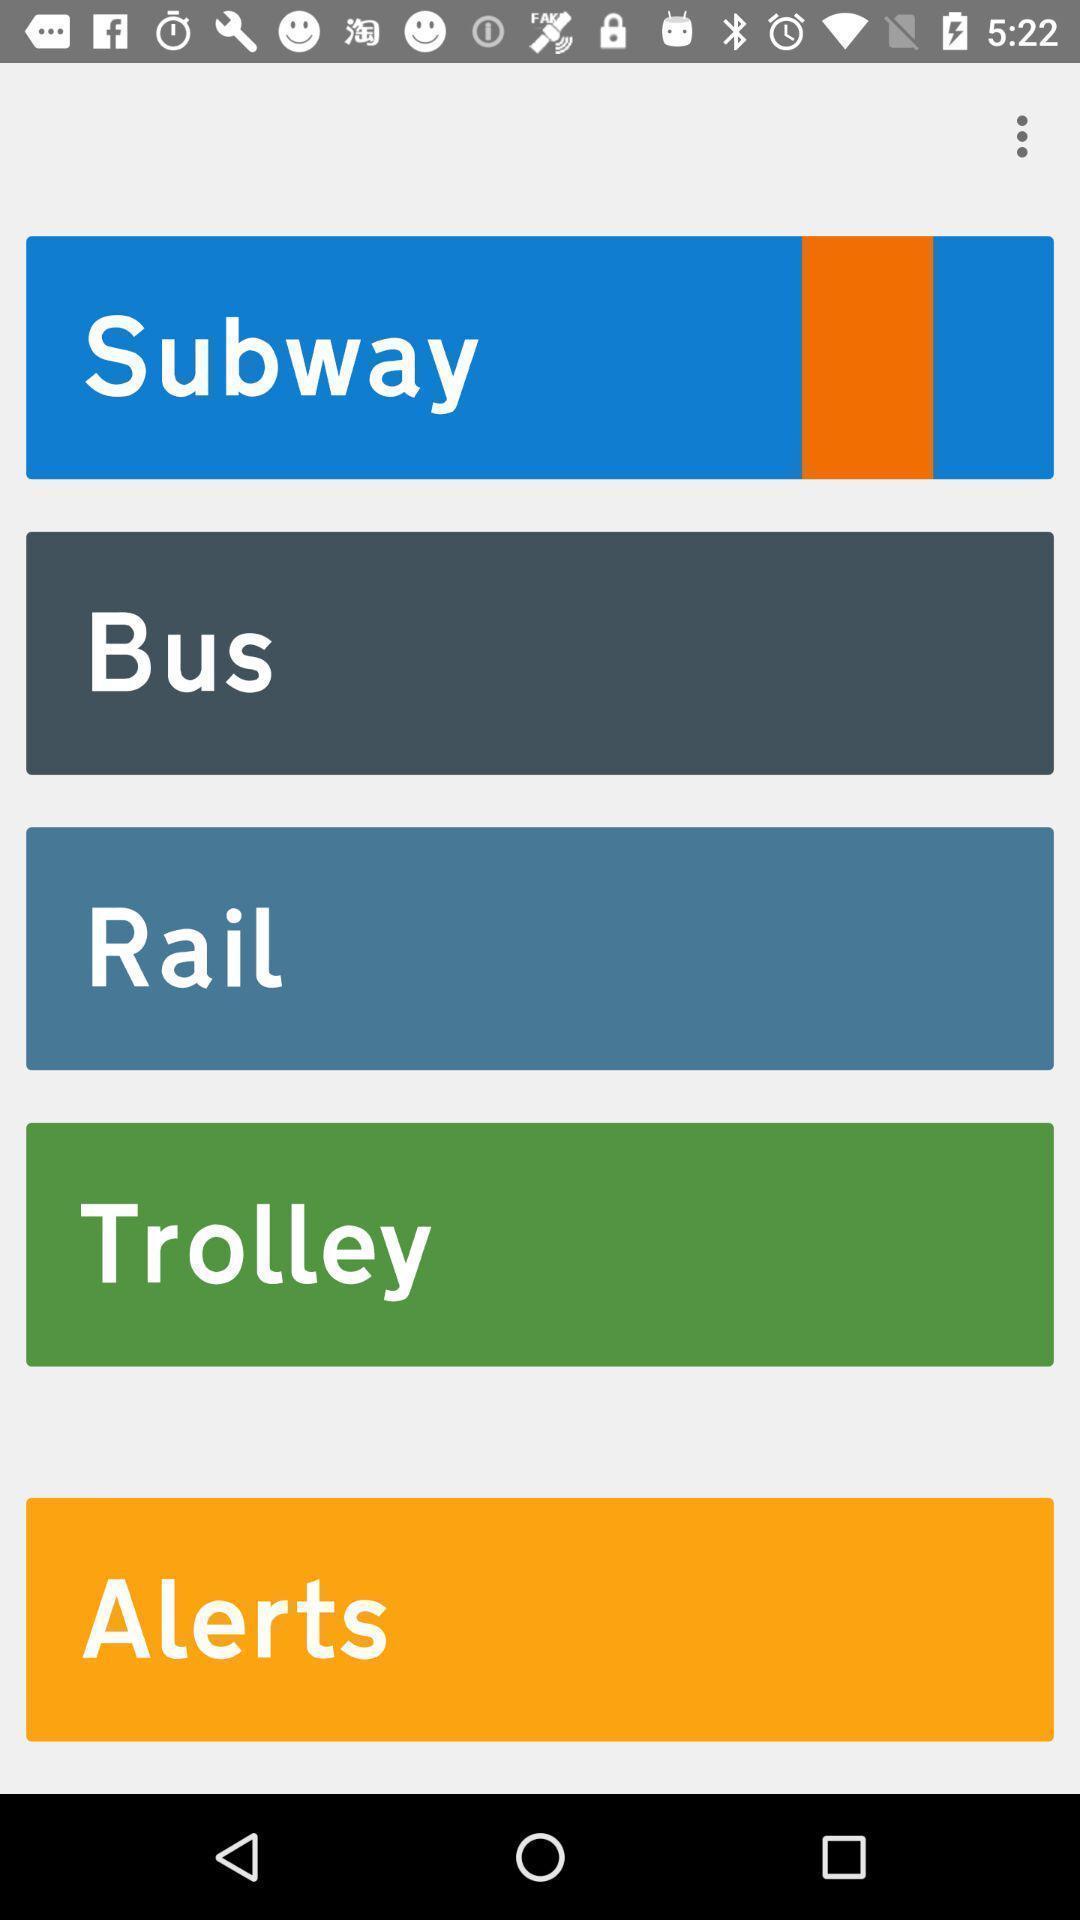Summarize the main components in this picture. Page showing different options on an app. 